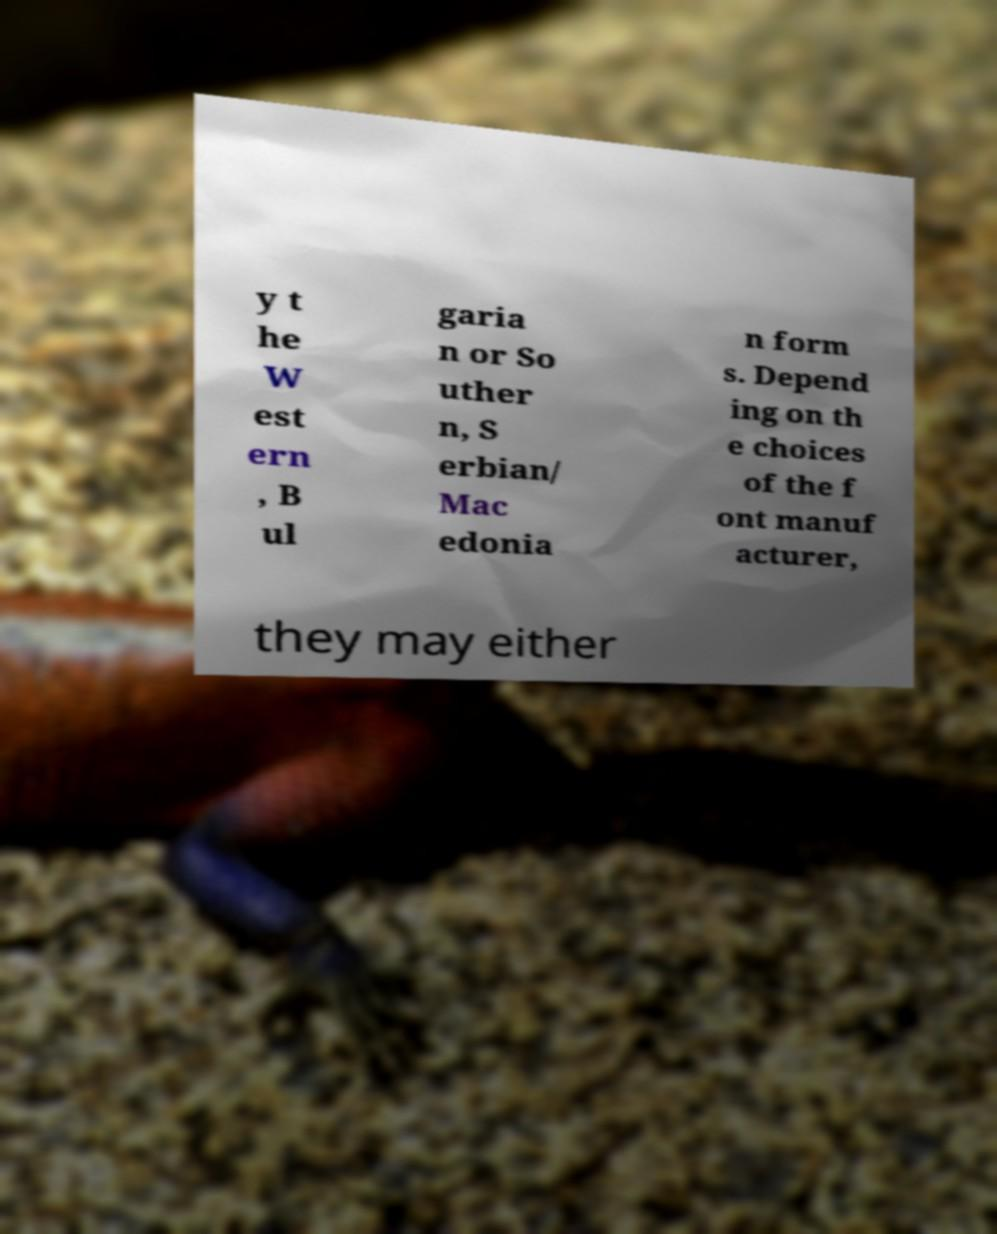There's text embedded in this image that I need extracted. Can you transcribe it verbatim? y t he W est ern , B ul garia n or So uther n, S erbian/ Mac edonia n form s. Depend ing on th e choices of the f ont manuf acturer, they may either 